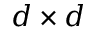Convert formula to latex. <formula><loc_0><loc_0><loc_500><loc_500>d \times d</formula> 